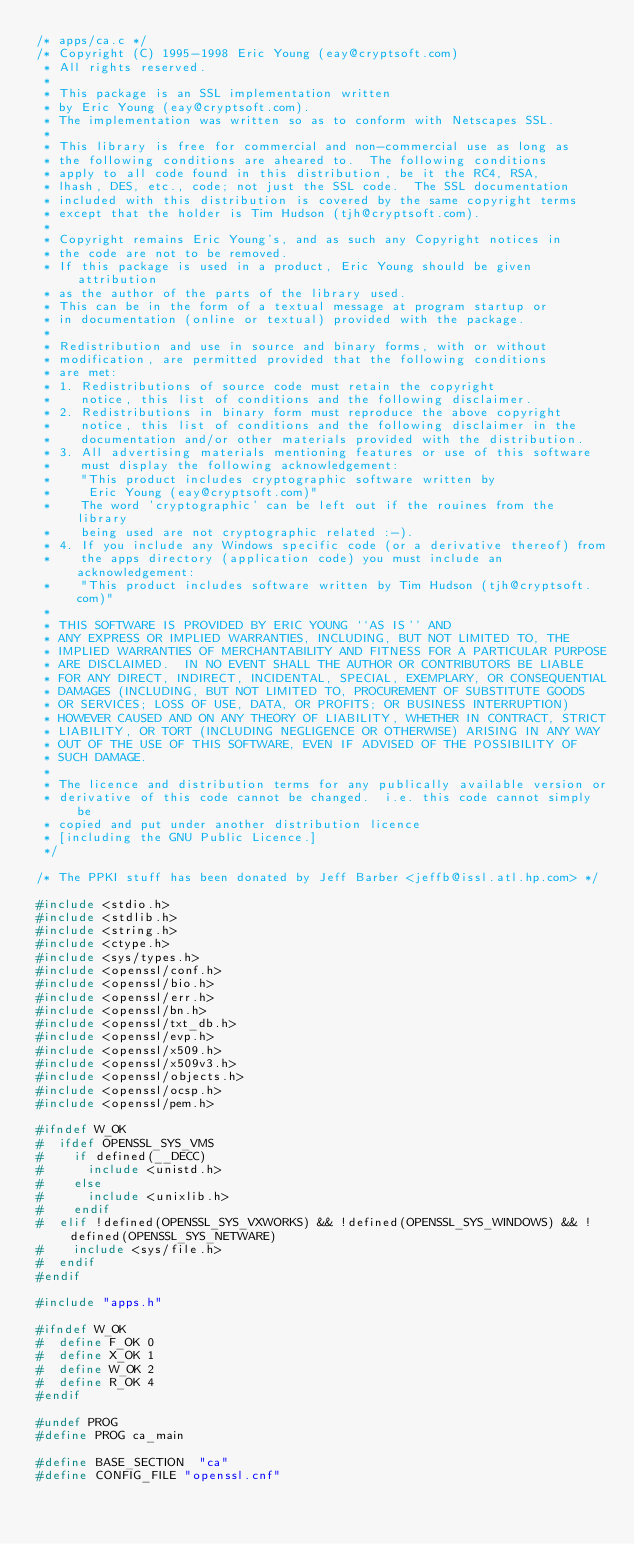Convert code to text. <code><loc_0><loc_0><loc_500><loc_500><_C_>/* apps/ca.c */
/* Copyright (C) 1995-1998 Eric Young (eay@cryptsoft.com)
 * All rights reserved.
 *
 * This package is an SSL implementation written
 * by Eric Young (eay@cryptsoft.com).
 * The implementation was written so as to conform with Netscapes SSL.
 * 
 * This library is free for commercial and non-commercial use as long as
 * the following conditions are aheared to.  The following conditions
 * apply to all code found in this distribution, be it the RC4, RSA,
 * lhash, DES, etc., code; not just the SSL code.  The SSL documentation
 * included with this distribution is covered by the same copyright terms
 * except that the holder is Tim Hudson (tjh@cryptsoft.com).
 * 
 * Copyright remains Eric Young's, and as such any Copyright notices in
 * the code are not to be removed.
 * If this package is used in a product, Eric Young should be given attribution
 * as the author of the parts of the library used.
 * This can be in the form of a textual message at program startup or
 * in documentation (online or textual) provided with the package.
 * 
 * Redistribution and use in source and binary forms, with or without
 * modification, are permitted provided that the following conditions
 * are met:
 * 1. Redistributions of source code must retain the copyright
 *    notice, this list of conditions and the following disclaimer.
 * 2. Redistributions in binary form must reproduce the above copyright
 *    notice, this list of conditions and the following disclaimer in the
 *    documentation and/or other materials provided with the distribution.
 * 3. All advertising materials mentioning features or use of this software
 *    must display the following acknowledgement:
 *    "This product includes cryptographic software written by
 *     Eric Young (eay@cryptsoft.com)"
 *    The word 'cryptographic' can be left out if the rouines from the library
 *    being used are not cryptographic related :-).
 * 4. If you include any Windows specific code (or a derivative thereof) from 
 *    the apps directory (application code) you must include an acknowledgement:
 *    "This product includes software written by Tim Hudson (tjh@cryptsoft.com)"
 * 
 * THIS SOFTWARE IS PROVIDED BY ERIC YOUNG ``AS IS'' AND
 * ANY EXPRESS OR IMPLIED WARRANTIES, INCLUDING, BUT NOT LIMITED TO, THE
 * IMPLIED WARRANTIES OF MERCHANTABILITY AND FITNESS FOR A PARTICULAR PURPOSE
 * ARE DISCLAIMED.  IN NO EVENT SHALL THE AUTHOR OR CONTRIBUTORS BE LIABLE
 * FOR ANY DIRECT, INDIRECT, INCIDENTAL, SPECIAL, EXEMPLARY, OR CONSEQUENTIAL
 * DAMAGES (INCLUDING, BUT NOT LIMITED TO, PROCUREMENT OF SUBSTITUTE GOODS
 * OR SERVICES; LOSS OF USE, DATA, OR PROFITS; OR BUSINESS INTERRUPTION)
 * HOWEVER CAUSED AND ON ANY THEORY OF LIABILITY, WHETHER IN CONTRACT, STRICT
 * LIABILITY, OR TORT (INCLUDING NEGLIGENCE OR OTHERWISE) ARISING IN ANY WAY
 * OUT OF THE USE OF THIS SOFTWARE, EVEN IF ADVISED OF THE POSSIBILITY OF
 * SUCH DAMAGE.
 * 
 * The licence and distribution terms for any publically available version or
 * derivative of this code cannot be changed.  i.e. this code cannot simply be
 * copied and put under another distribution licence
 * [including the GNU Public Licence.]
 */

/* The PPKI stuff has been donated by Jeff Barber <jeffb@issl.atl.hp.com> */

#include <stdio.h>
#include <stdlib.h>
#include <string.h>
#include <ctype.h>
#include <sys/types.h>
#include <openssl/conf.h>
#include <openssl/bio.h>
#include <openssl/err.h>
#include <openssl/bn.h>
#include <openssl/txt_db.h>
#include <openssl/evp.h>
#include <openssl/x509.h>
#include <openssl/x509v3.h>
#include <openssl/objects.h>
#include <openssl/ocsp.h>
#include <openssl/pem.h>

#ifndef W_OK
#  ifdef OPENSSL_SYS_VMS
#    if defined(__DECC)
#      include <unistd.h>
#    else
#      include <unixlib.h>
#    endif
#  elif !defined(OPENSSL_SYS_VXWORKS) && !defined(OPENSSL_SYS_WINDOWS) && !defined(OPENSSL_SYS_NETWARE)
#    include <sys/file.h>
#  endif
#endif

#include "apps.h"

#ifndef W_OK
#  define F_OK 0
#  define X_OK 1
#  define W_OK 2
#  define R_OK 4
#endif

#undef PROG
#define PROG ca_main

#define BASE_SECTION	"ca"
#define CONFIG_FILE "openssl.cnf"
</code> 